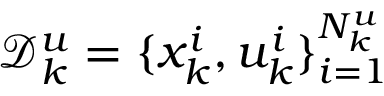<formula> <loc_0><loc_0><loc_500><loc_500>\mathcal { D } _ { k } ^ { u } = \{ x _ { k } ^ { i } , u _ { k } ^ { i } \} _ { i = 1 } ^ { N _ { k } ^ { u } }</formula> 